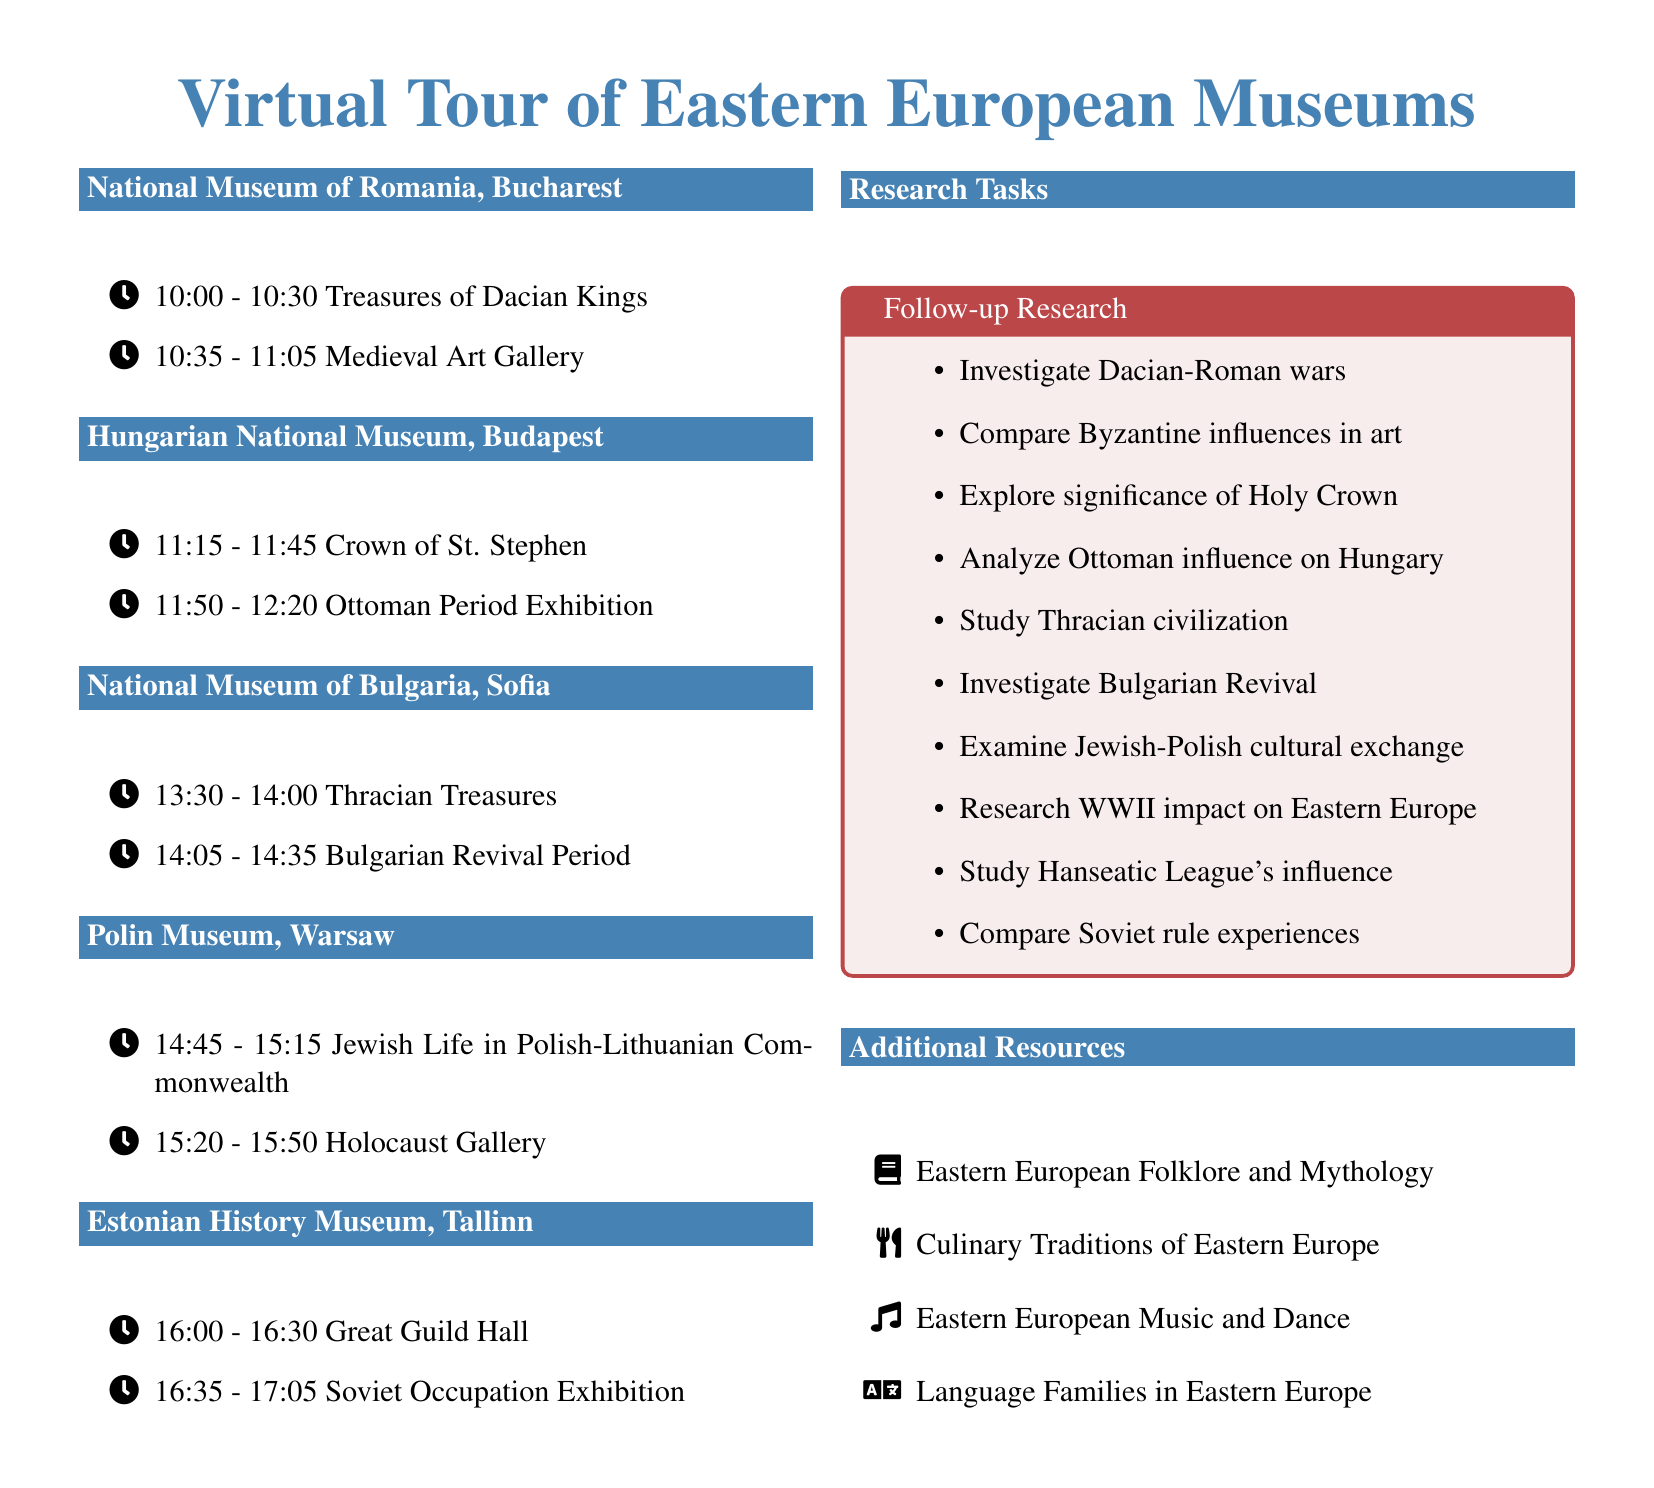what is the time slot for the "Crown of St. Stephen"? The time slot for the "Crown of St. Stephen" is specified in the document as 11:15 - 11:45.
Answer: 11:15 - 11:45 which museum is located in Bucharest, Romania? The museum located in Bucharest, Romania, as stated in the document, is the National Museum of Romania.
Answer: National Museum of Romania how many exhibits are listed for the Polish museum? The Polish museum, Polin Museum, has two exhibits listed in the document.
Answer: 2 what is the research task for the "Soviet Occupation Exhibition"? The research task for the "Soviet Occupation Exhibition" in the document involves comparing experiences of Baltic countries under Soviet rule with others.
Answer: Compare experiences of Baltic countries under Soviet rule name one additional resource listed in the document. The document includes several additional resources, one of which is Eastern European Folklore and Mythology.
Answer: Eastern European Folklore and Mythology what is the last exhibit listed for the Estonian History Museum? The last exhibit for the Estonian History Museum as per the document is the "Soviet Occupation Exhibition".
Answer: Soviet Occupation Exhibition 